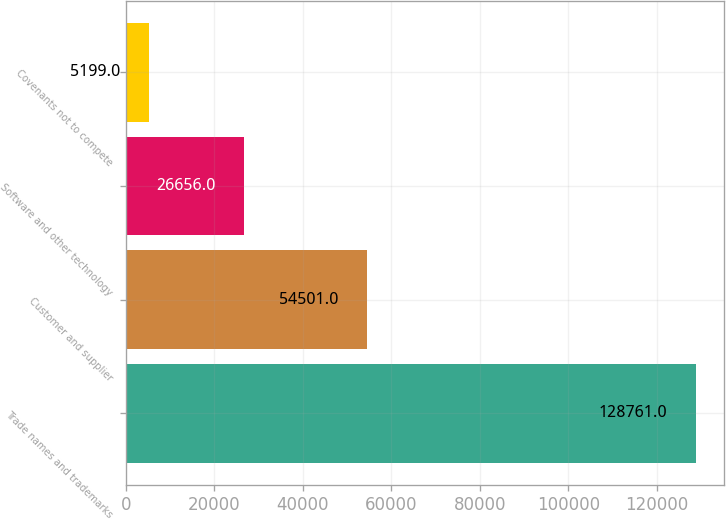Convert chart. <chart><loc_0><loc_0><loc_500><loc_500><bar_chart><fcel>Trade names and trademarks<fcel>Customer and supplier<fcel>Software and other technology<fcel>Covenants not to compete<nl><fcel>128761<fcel>54501<fcel>26656<fcel>5199<nl></chart> 